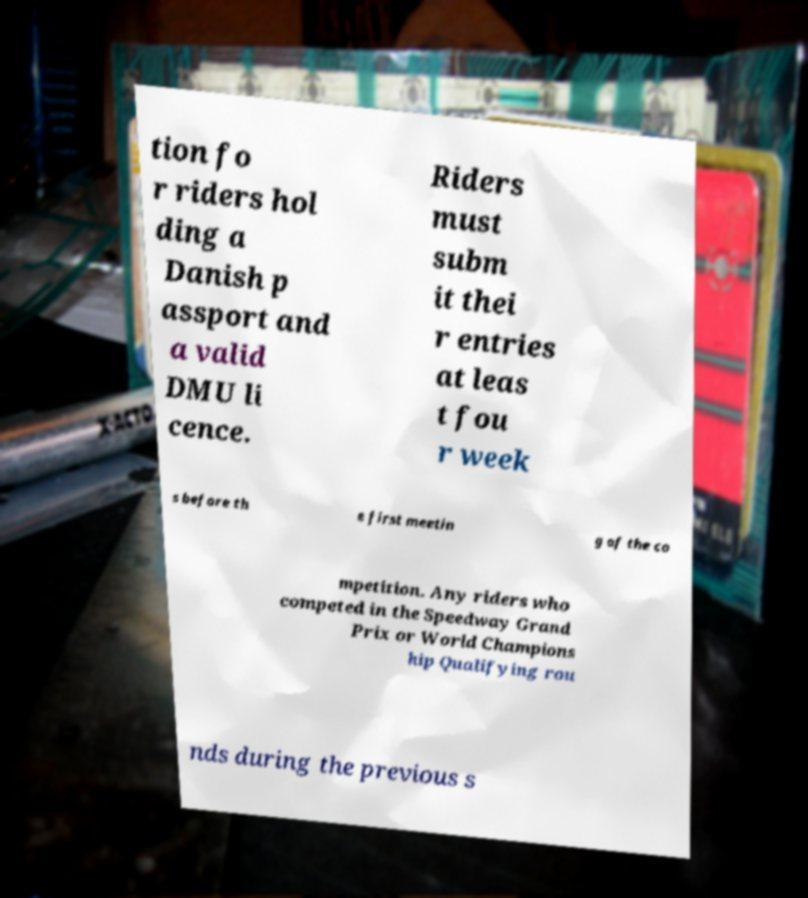Please identify and transcribe the text found in this image. tion fo r riders hol ding a Danish p assport and a valid DMU li cence. Riders must subm it thei r entries at leas t fou r week s before th e first meetin g of the co mpetition. Any riders who competed in the Speedway Grand Prix or World Champions hip Qualifying rou nds during the previous s 